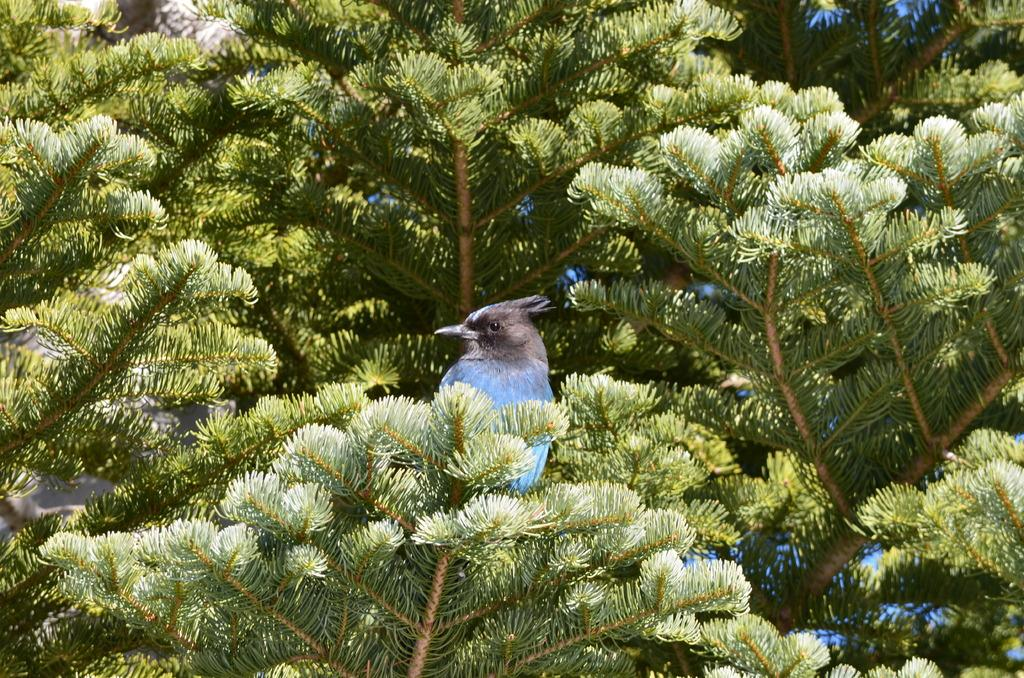Where was the picture taken? The picture was clicked outside. What can be seen on the tree in the image? There is a bird on a tree in the image. How would you describe the tree in the image? The tree has stems and branches visible. What is visible in the background of the image? There is a sky visible in the background of the image. How many donkeys are participating in the competition in the image? There are no donkeys or competitions present in the image. Can you tell me the color of the chickens in the image? There are no chickens present in the image. 